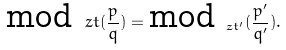Convert formula to latex. <formula><loc_0><loc_0><loc_500><loc_500>\text {mod} _ { \ } z t ( \frac { p } { q } ) = \text {mod} _ { \ z t ^ { \prime } } ( \frac { p ^ { \prime } } { q ^ { \prime } } ) .</formula> 